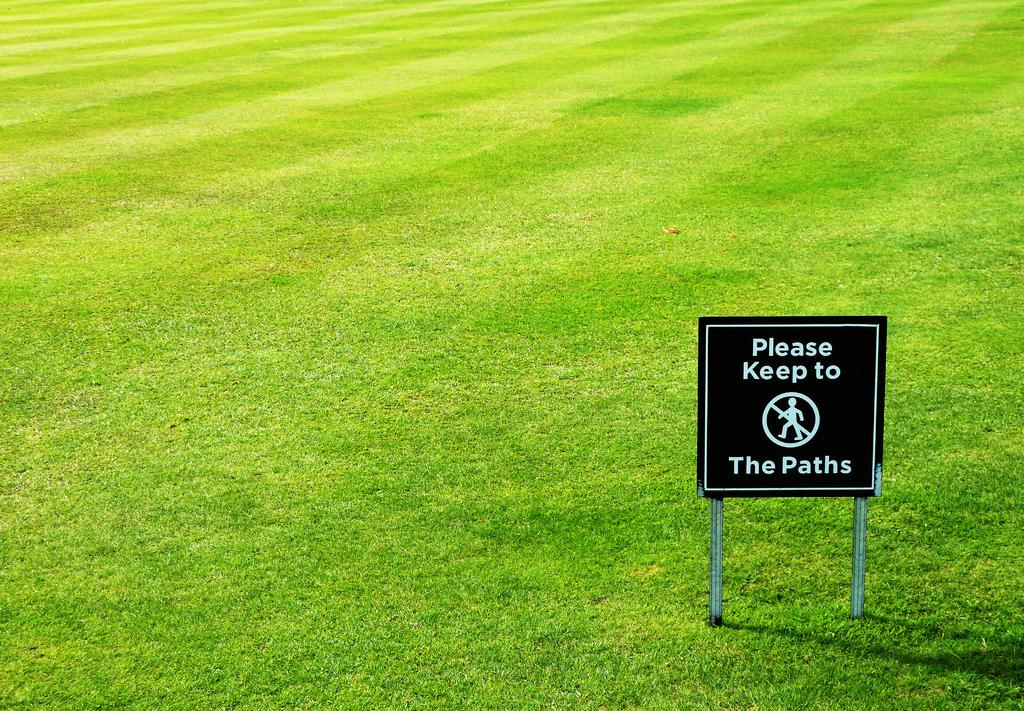What is located on the right side of the image? There is a sign board on the right side of the image. Where is the sign board situated? The sign board is on a grassland. What type of environment is visible in the image? There is grassland around the area of the image. What type of bottle can be seen in the hands of the person playing the guitar in the image? There is no person playing a guitar or holding a bottle in the image. Can you describe the twig that the person is using to play the guitar in the image? There is no person playing a guitar or using a twig in the image. 